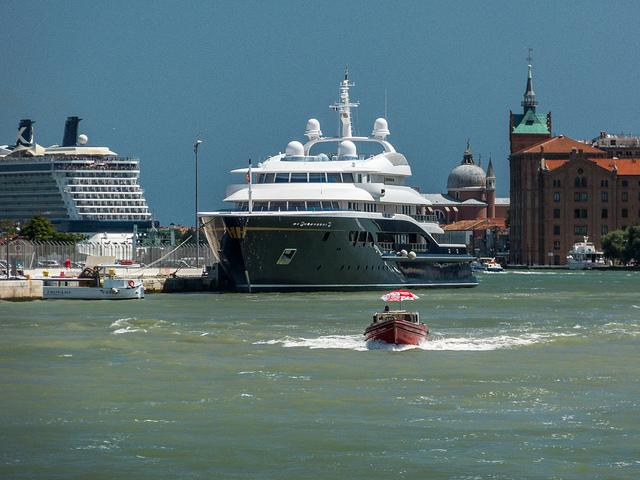Which direction is the large gray ship going? left 